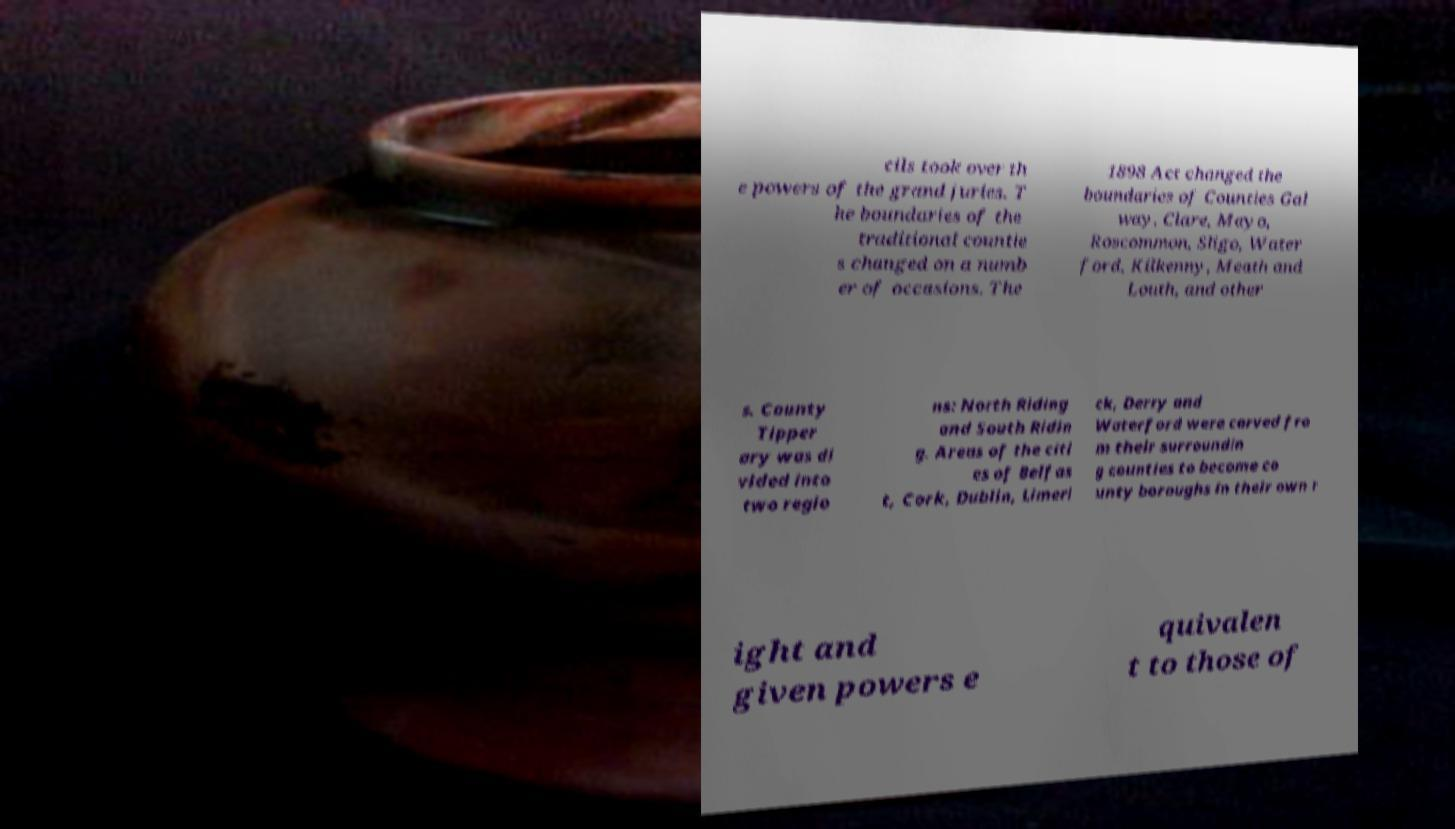For documentation purposes, I need the text within this image transcribed. Could you provide that? cils took over th e powers of the grand juries. T he boundaries of the traditional countie s changed on a numb er of occasions. The 1898 Act changed the boundaries of Counties Gal way, Clare, Mayo, Roscommon, Sligo, Water ford, Kilkenny, Meath and Louth, and other s. County Tipper ary was di vided into two regio ns: North Riding and South Ridin g. Areas of the citi es of Belfas t, Cork, Dublin, Limeri ck, Derry and Waterford were carved fro m their surroundin g counties to become co unty boroughs in their own r ight and given powers e quivalen t to those of 